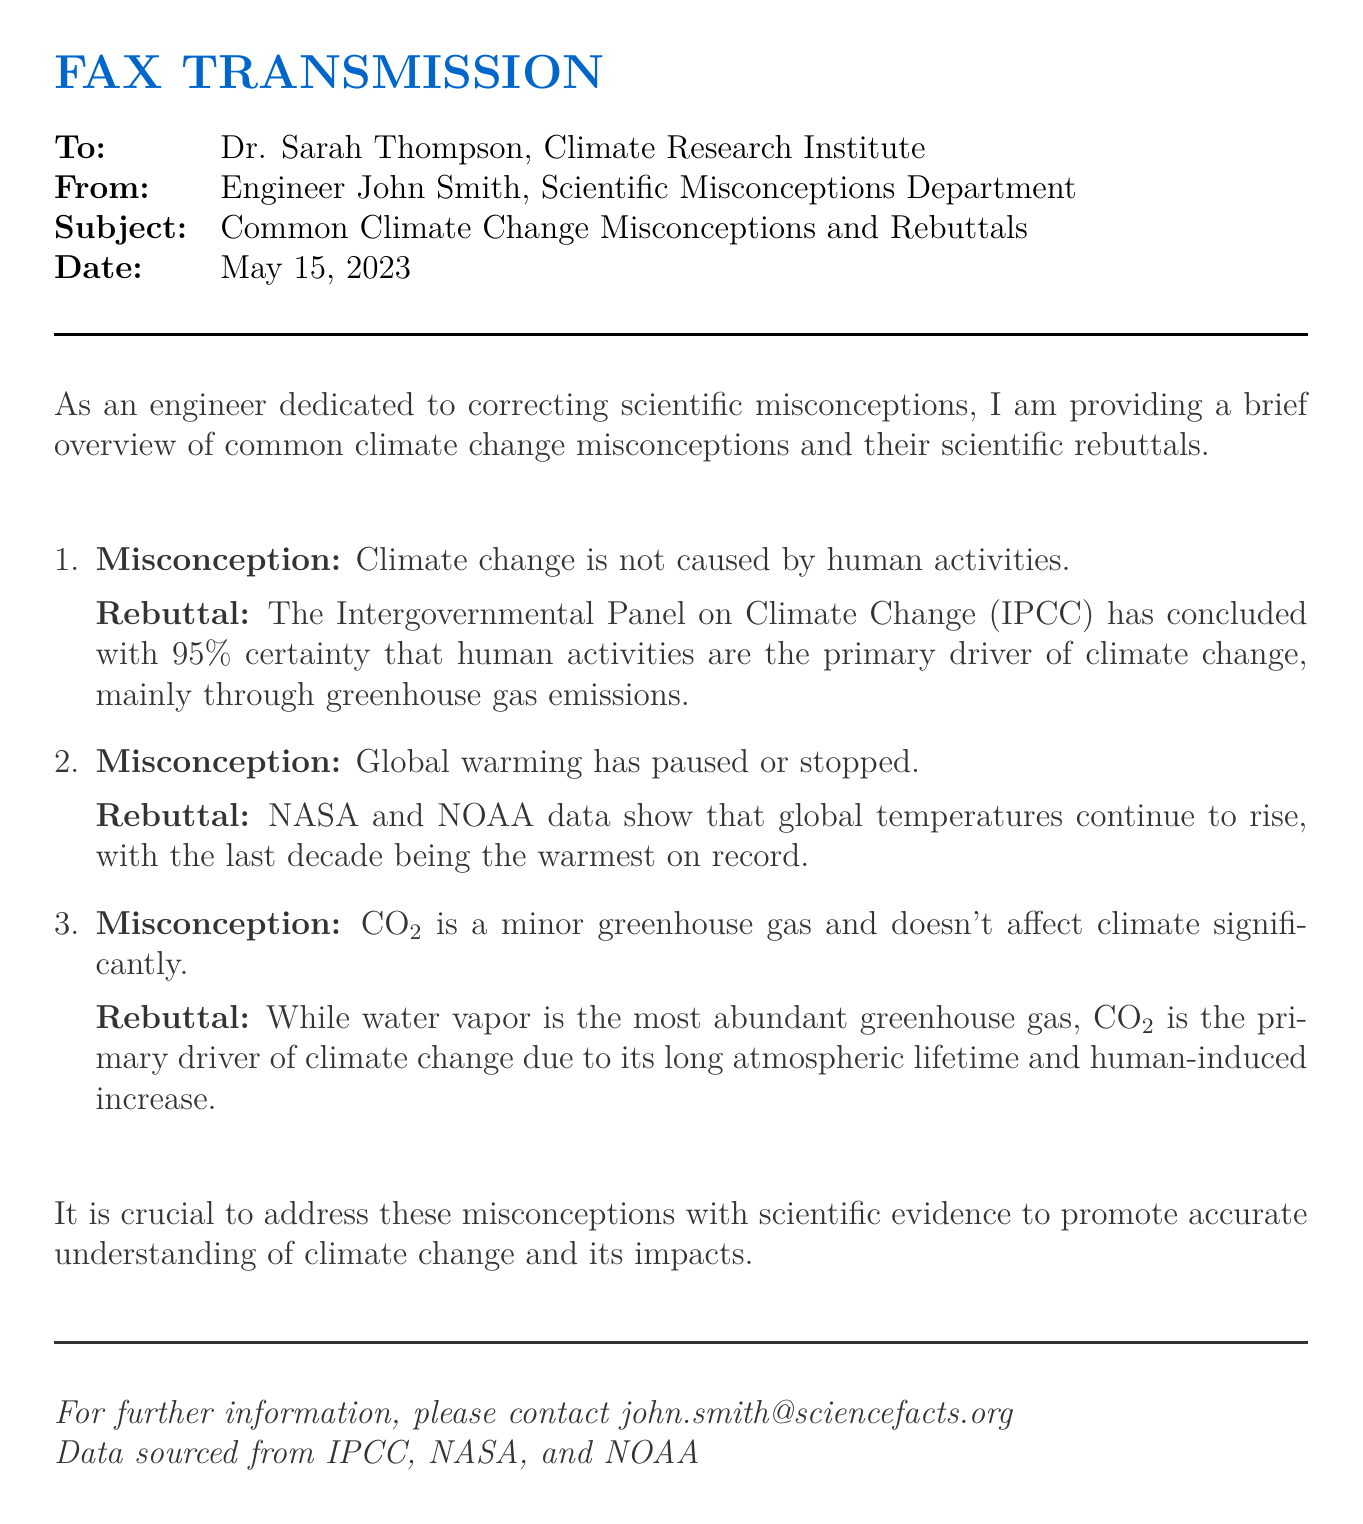What is the date of the fax? The date is specified in the header section of the fax document as May 15, 2023.
Answer: May 15, 2023 Who is the recipient of the fax? The recipient's name and affiliation are provided at the beginning of the document as Dr. Sarah Thompson, Climate Research Institute.
Answer: Dr. Sarah Thompson What organization concluded that human activities are the primary driver of climate change? The document cites the Intergovernmental Panel on Climate Change as the organization that reached this conclusion.
Answer: Intergovernmental Panel on Climate Change What percentage of certainty does the IPCC have about human activities causing climate change? The fax states that the IPCC has concluded this with 95 percent certainty.
Answer: 95% What is the primary greenhouse gas mentioned that is human-induced? The document refers specifically to carbon dioxide (CO2) as the primary human-induced greenhouse gas.
Answer: CO2 What does NASA and NOAA data indicate about global temperatures? The rebuttal mentions that NASA and NOAA data show that global temperatures continue to rise and that the last decade was the warmest on record.
Answer: Continue to rise What is the main topic of this fax? The main topic is about common misconceptions related to climate change and their scientific rebuttals, as indicated in the subject line.
Answer: Common climate change misconceptions What email address is provided for further information? The fax includes a contact email address for further information, which is john.smith@sciencefacts.org.
Answer: john.smith@sciencefacts.org What is the purpose of addressing climate change misconceptions? The document states the importance of addressing misconceptions to promote accurate understanding of climate change and its impacts.
Answer: Promote accurate understanding 